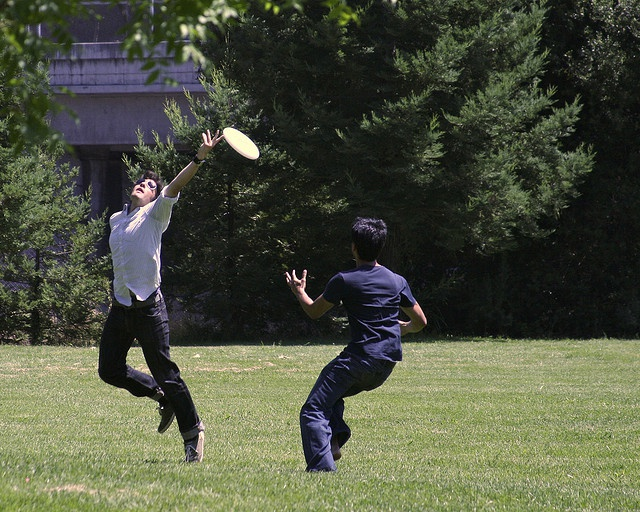Describe the objects in this image and their specific colors. I can see people in black, gray, and darkgray tones, people in black, gray, navy, and purple tones, and frisbee in black, lightyellow, gray, and tan tones in this image. 